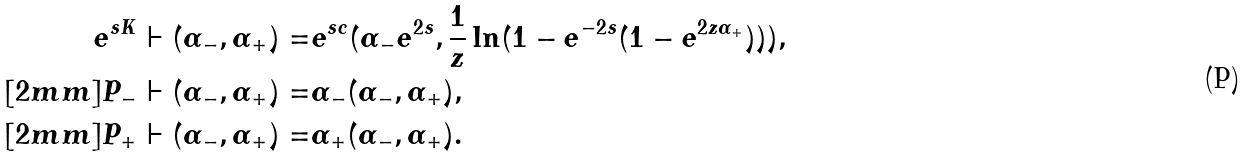<formula> <loc_0><loc_0><loc_500><loc_500>e ^ { s K } \vdash ( \alpha _ { - } , \alpha _ { + } ) = & e ^ { s c } ( \alpha _ { - } e ^ { 2 s } , \frac { 1 } { z } \ln ( 1 - e ^ { - 2 s } ( 1 - e ^ { 2 { z } \alpha _ { + } } ) ) ) , \\ [ 2 m m ] P _ { - } \vdash ( \alpha _ { - } , \alpha _ { + } ) = & \alpha _ { - } ( \alpha _ { - } , \alpha _ { + } ) , \\ [ 2 m m ] P _ { + } \vdash ( \alpha _ { - } , \alpha _ { + } ) = & \alpha _ { + } ( \alpha _ { - } , \alpha _ { + } ) .</formula> 